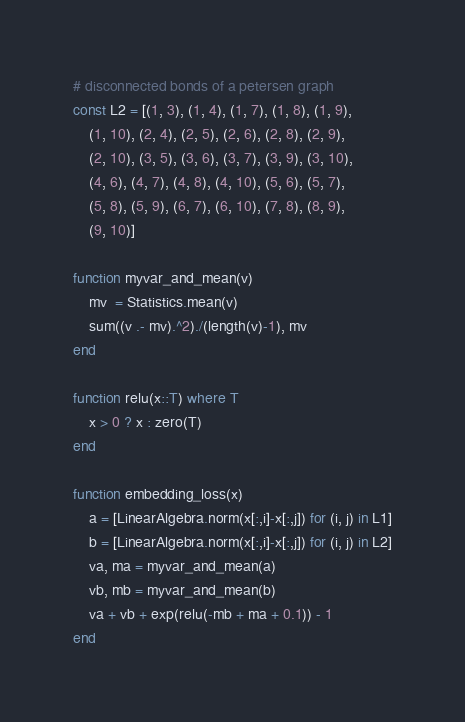Convert code to text. <code><loc_0><loc_0><loc_500><loc_500><_Julia_># disconnected bonds of a petersen graph
const L2 = [(1, 3), (1, 4), (1, 7), (1, 8), (1, 9),
    (1, 10), (2, 4), (2, 5), (2, 6), (2, 8), (2, 9),
    (2, 10), (3, 5), (3, 6), (3, 7), (3, 9), (3, 10),
    (4, 6), (4, 7), (4, 8), (4, 10), (5, 6), (5, 7),
    (5, 8), (5, 9), (6, 7), (6, 10), (7, 8), (8, 9),
    (9, 10)]

function myvar_and_mean(v)
    mv  = Statistics.mean(v)
    sum((v .- mv).^2)./(length(v)-1), mv
end

function relu(x::T) where T
    x > 0 ? x : zero(T)
end

function embedding_loss(x)
    a = [LinearAlgebra.norm(x[:,i]-x[:,j]) for (i, j) in L1]
    b = [LinearAlgebra.norm(x[:,i]-x[:,j]) for (i, j) in L2]
    va, ma = myvar_and_mean(a)
    vb, mb = myvar_and_mean(b)
    va + vb + exp(relu(-mb + ma + 0.1)) - 1
end
</code> 